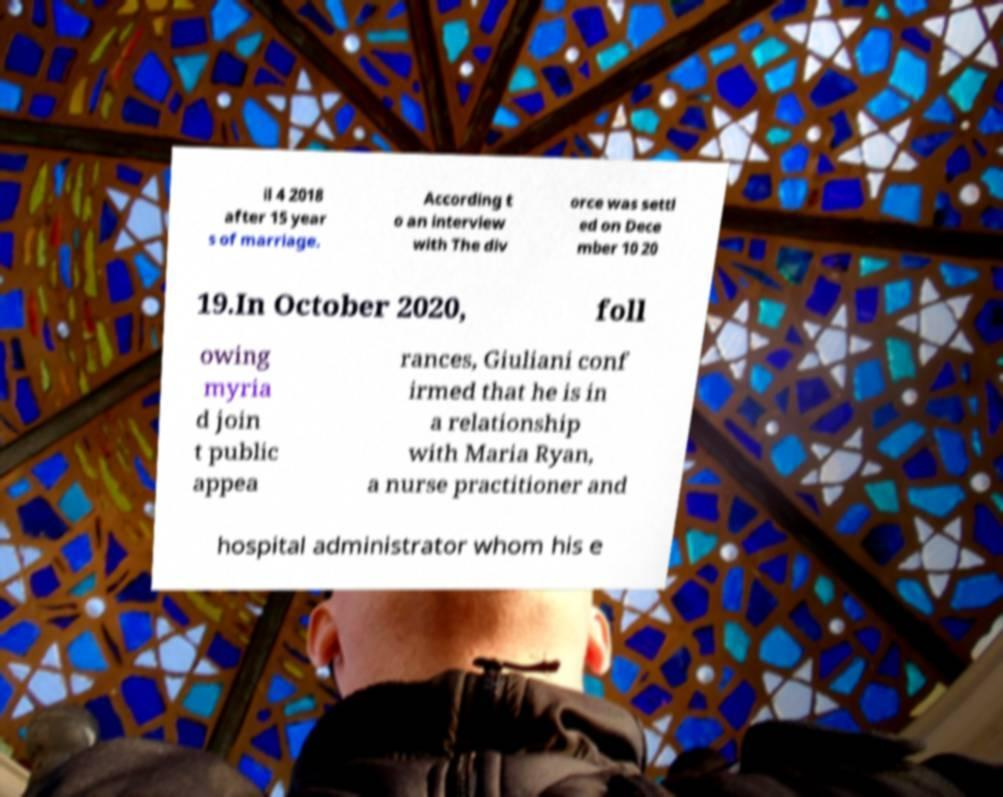Could you extract and type out the text from this image? il 4 2018 after 15 year s of marriage. According t o an interview with The div orce was settl ed on Dece mber 10 20 19.In October 2020, foll owing myria d join t public appea rances, Giuliani conf irmed that he is in a relationship with Maria Ryan, a nurse practitioner and hospital administrator whom his e 